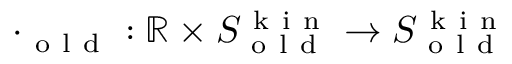<formula> <loc_0><loc_0><loc_500><loc_500>\cdot _ { o l d } \colon \mathbb { R } \times S _ { o l d } ^ { k i n } \to S _ { o l d } ^ { k i n }</formula> 